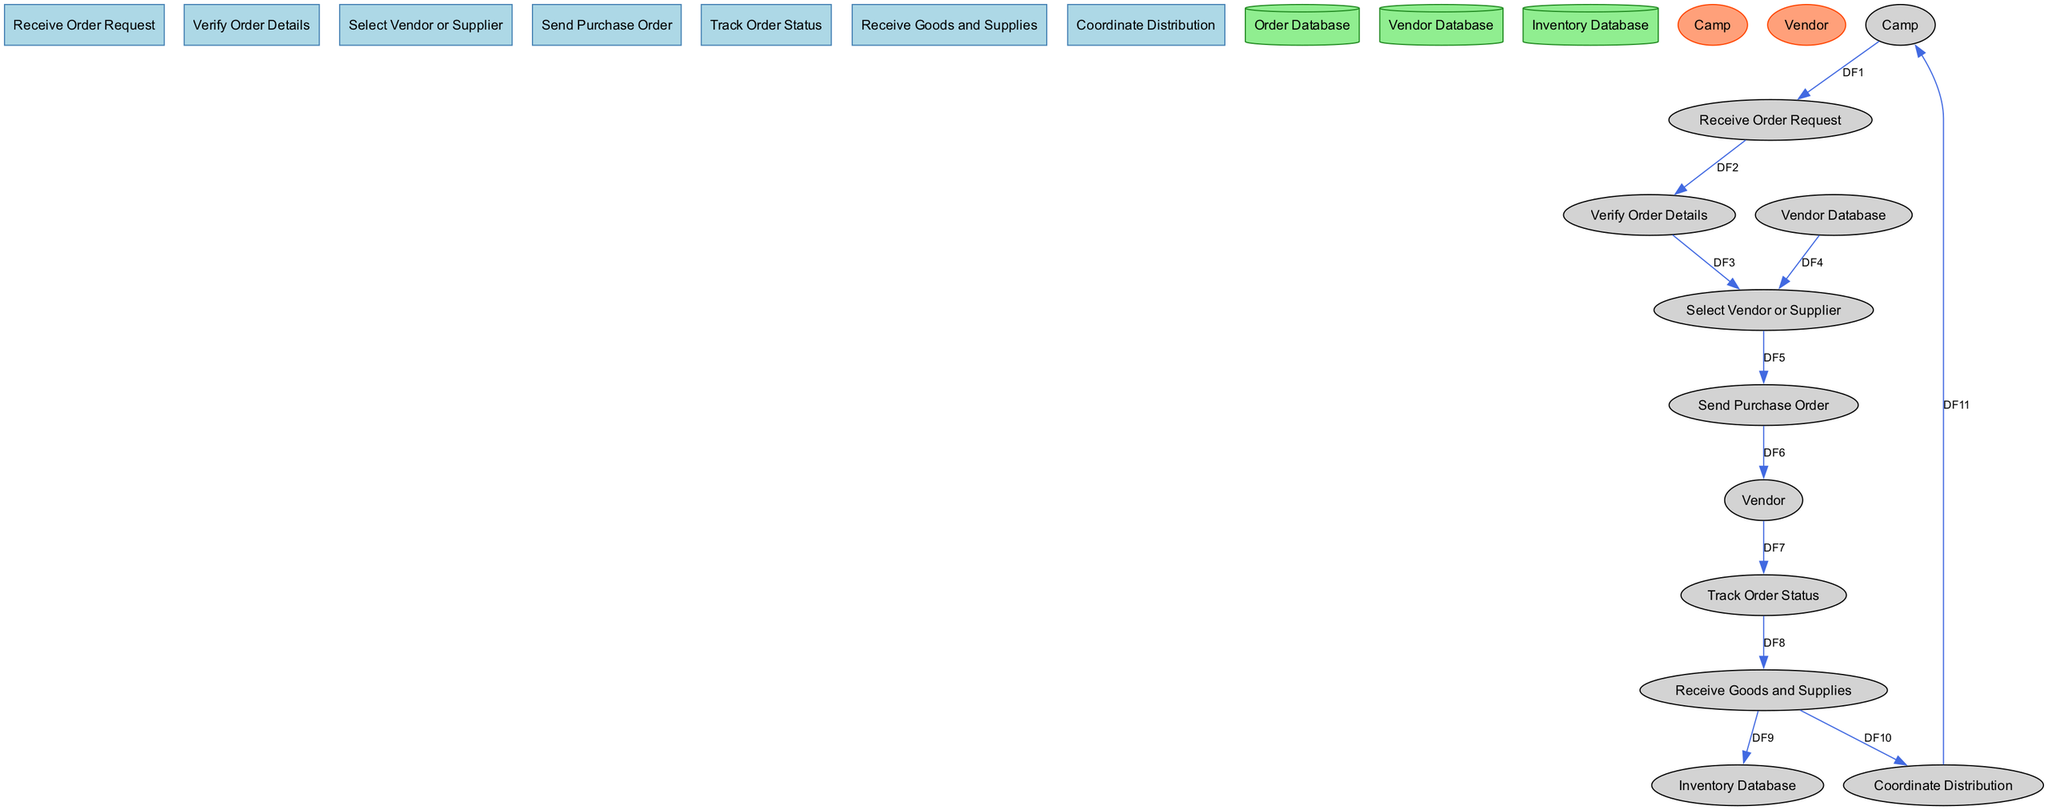What is the first process in the diagram? The first process is "Receive Order Request," which is identified as P1 in the diagram. It is the starting point for handling order requests from the camp.
Answer: Receive Order Request How many processes are depicted in the diagram? There are seven processes listed in the diagram related to vendor and supplier communication and order fulfillment.
Answer: Seven Which external entity receives distributed goods? The external entity that receives distributed goods is the "Camp," which is represented as E1 in the diagram.
Answer: Camp What is the purpose of the "Verify Order Details" process? The purpose of the "Verify Order Details" process is to check the accuracy and feasibility of the order details received from the camp before proceeding further in the workflow.
Answer: Check accuracy and feasibility Which data store is updated when goods are received? The data store that is updated when goods are received is the "Inventory Database," identified as D3 in the diagram. It tracks inventory levels of the received goods and supplies.
Answer: Inventory Database What data flow connects the "Select Vendor or Supplier" process to the "Send Purchase Order" process? The data flow that connects these processes is identified as DF5, which transmits selected vendor or supplier details and order information from "Select Vendor or Supplier" to "Send Purchase Order."
Answer: DF5 How does the "Track Order Status" process receive updates? The "Track Order Status" process receives updates through the data flow identified as DF7, which brings order status updates provided directly by the vendor, allowing monitoring of the order's progress.
Answer: DF7 What is the last action performed in the diagram? The last action performed in the diagram is the "Coordinate Distribution" process, which distributes the received goods and supplies to the camp, as indicated by the data flow identified as DF11.
Answer: Coordinate Distribution 